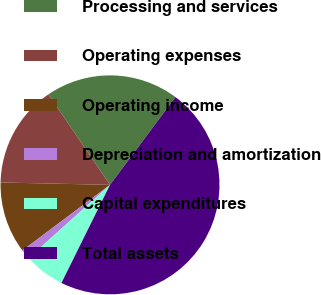Convert chart to OTSL. <chart><loc_0><loc_0><loc_500><loc_500><pie_chart><fcel>Processing and services<fcel>Operating expenses<fcel>Operating income<fcel>Depreciation and amortization<fcel>Capital expenditures<fcel>Total assets<nl><fcel>19.71%<fcel>15.14%<fcel>10.58%<fcel>1.44%<fcel>6.01%<fcel>47.12%<nl></chart> 